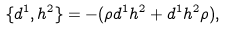Convert formula to latex. <formula><loc_0><loc_0><loc_500><loc_500>\{ d ^ { 1 } , h ^ { 2 } \} = - ( \rho d ^ { 1 } h ^ { 2 } + d ^ { 1 } h ^ { 2 } \rho ) ,</formula> 